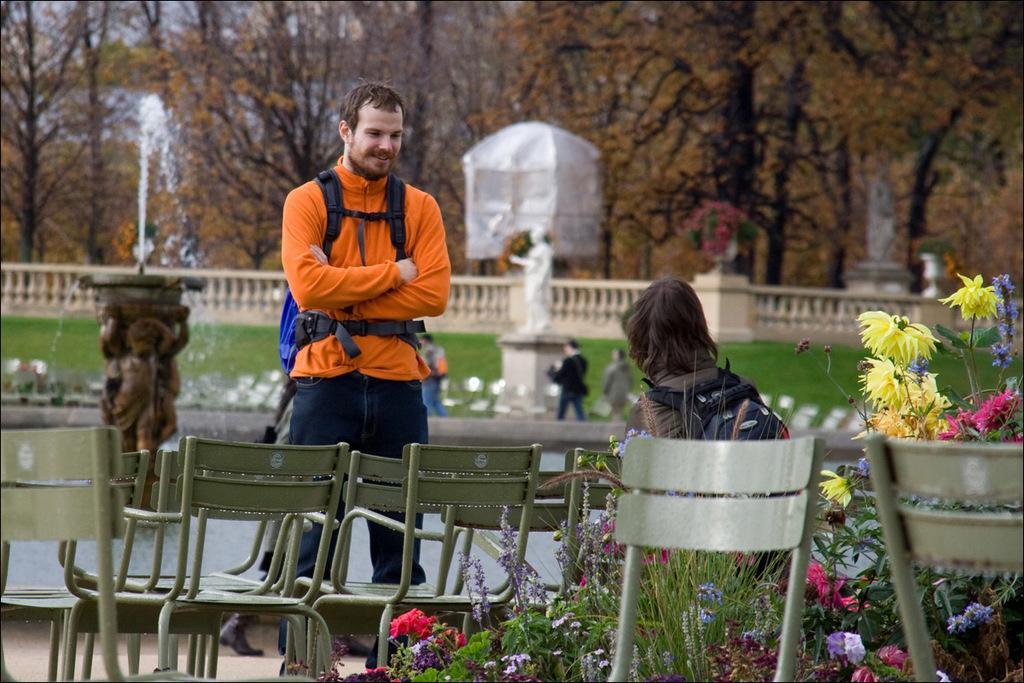Can you describe this image briefly? In this image there are two people one person is sitting on chair, and one person is standing and both of them are wearing bags. And at the bottom there are some chairs and flower bouquets, and there is a walkway. And in the background there is a pond, fountain, railing, grass, statues and two people are walking and there are trees and some object. 